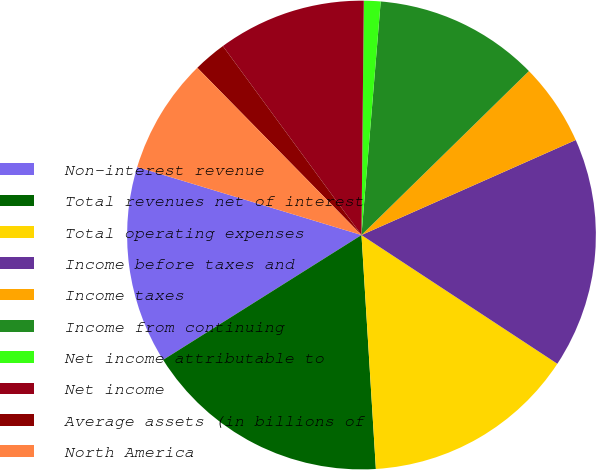<chart> <loc_0><loc_0><loc_500><loc_500><pie_chart><fcel>Non-interest revenue<fcel>Total revenues net of interest<fcel>Total operating expenses<fcel>Income before taxes and<fcel>Income taxes<fcel>Income from continuing<fcel>Net income attributable to<fcel>Net income<fcel>Average assets (in billions of<fcel>North America<nl><fcel>13.63%<fcel>17.04%<fcel>14.77%<fcel>15.9%<fcel>5.69%<fcel>11.36%<fcel>1.15%<fcel>10.23%<fcel>2.28%<fcel>7.96%<nl></chart> 